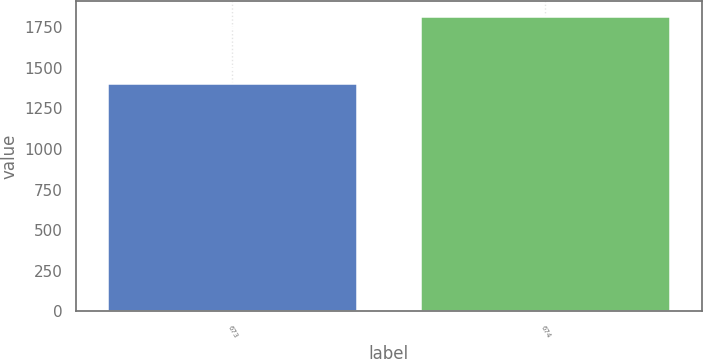Convert chart. <chart><loc_0><loc_0><loc_500><loc_500><bar_chart><fcel>673<fcel>674<nl><fcel>1404.4<fcel>1819<nl></chart> 